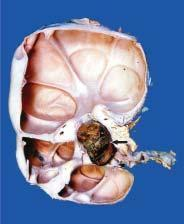what is enlarged and heavy?
Answer the question using a single word or phrase. Kidney 